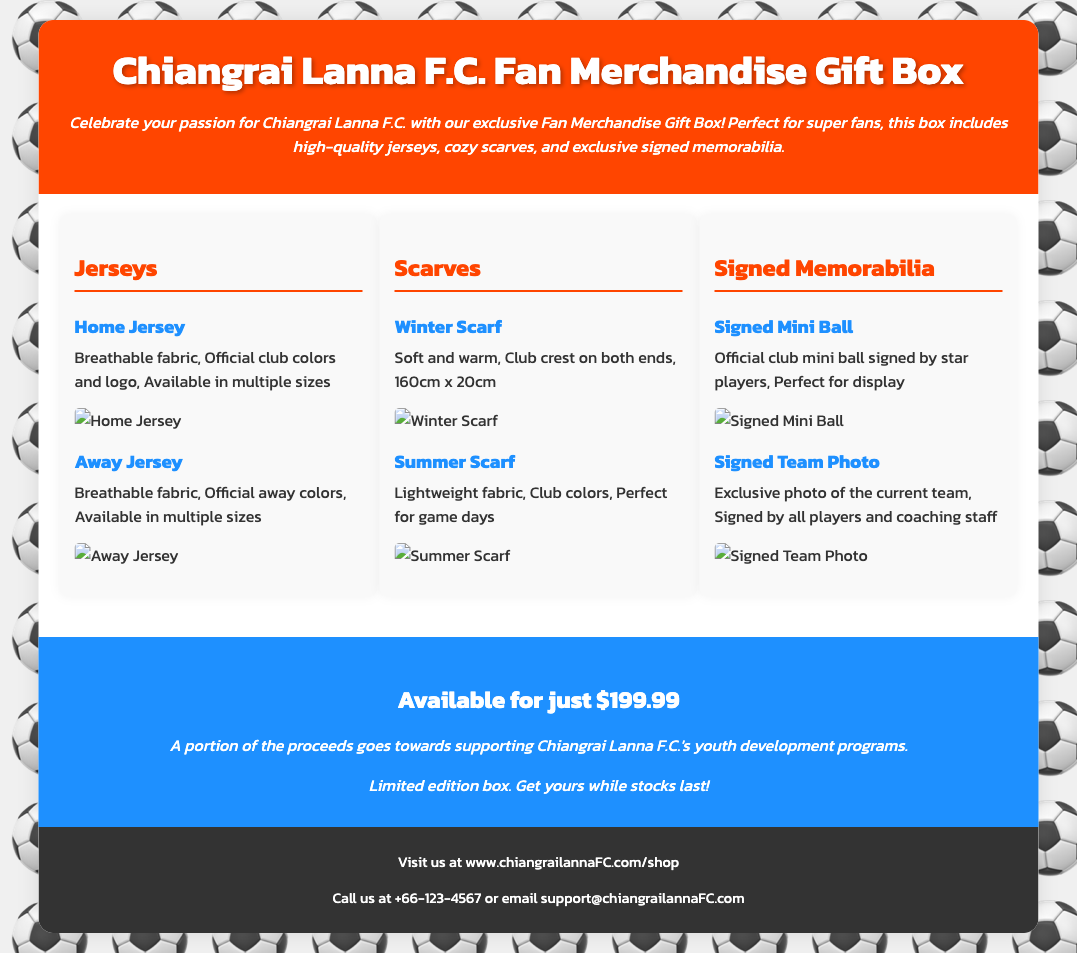what is included in the gift box? The gift box includes jerseys, scarves, and signed memorabilia.
Answer: jerseys, scarves, signed memorabilia how much does the gift box cost? The gift box is available for just $199.99.
Answer: $199.99 what is the size of the Winter Scarf? The Winter Scarf is 160cm x 20cm.
Answer: 160cm x 20cm what type of fabric is used for the Home Jersey? The Home Jersey is made of breathable fabric.
Answer: breathable fabric what portion of the proceeds benefits youth programs? A portion of the proceeds goes towards supporting Chiangrai Lanna F.C.'s youth development programs.
Answer: supporting youth development programs how many types of jerseys are mentioned? Two types of jerseys are mentioned: Home Jersey and Away Jersey.
Answer: two types who signs the mini ball? The mini ball is signed by star players.
Answer: star players what is on both ends of the Winter Scarf? The Winter Scarf has the club crest on both ends.
Answer: club crest what type of photo is included in the signed memorabilia? The signed memorabilia includes an exclusive photo of the current team.
Answer: exclusive team photo 